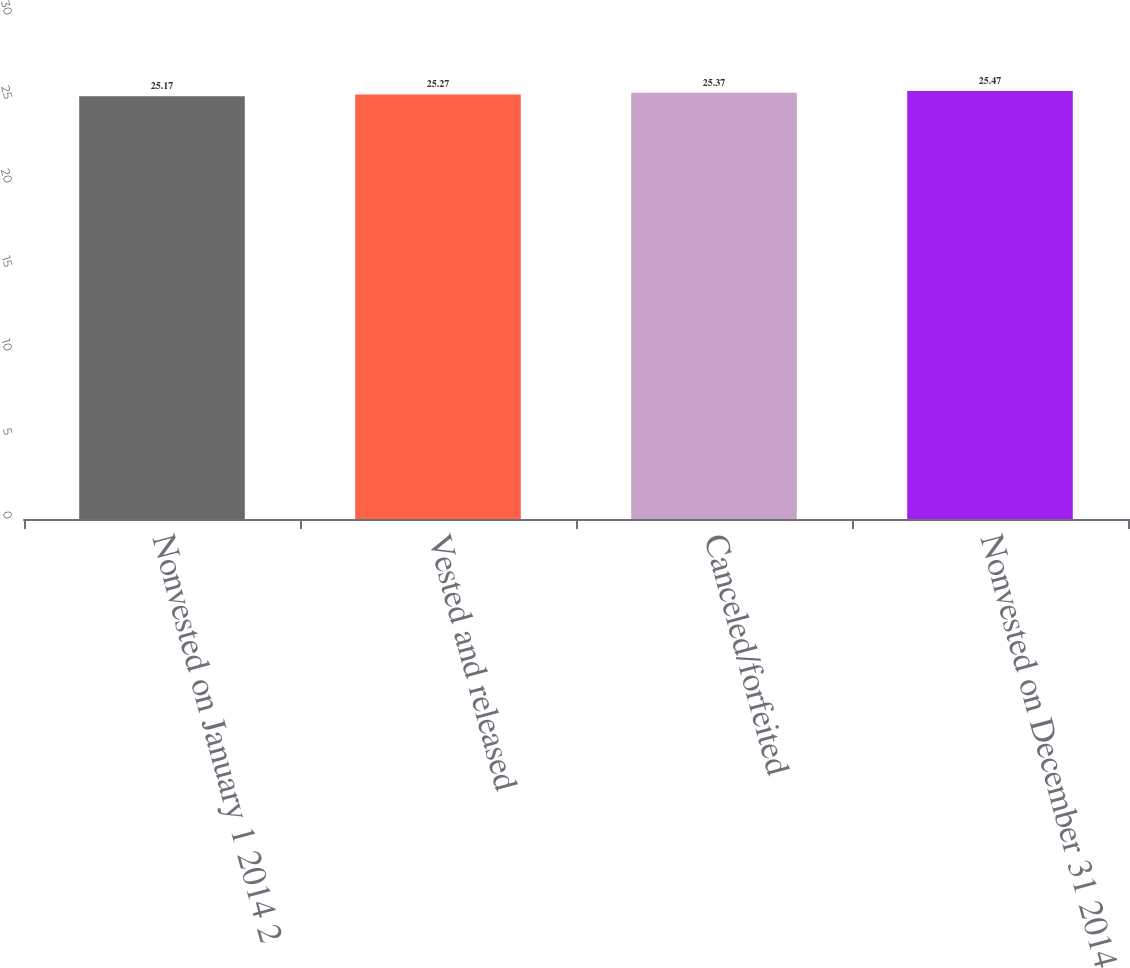Convert chart to OTSL. <chart><loc_0><loc_0><loc_500><loc_500><bar_chart><fcel>Nonvested on January 1 2014 2<fcel>Vested and released<fcel>Canceled/forfeited<fcel>Nonvested on December 31 2014<nl><fcel>25.17<fcel>25.27<fcel>25.37<fcel>25.47<nl></chart> 